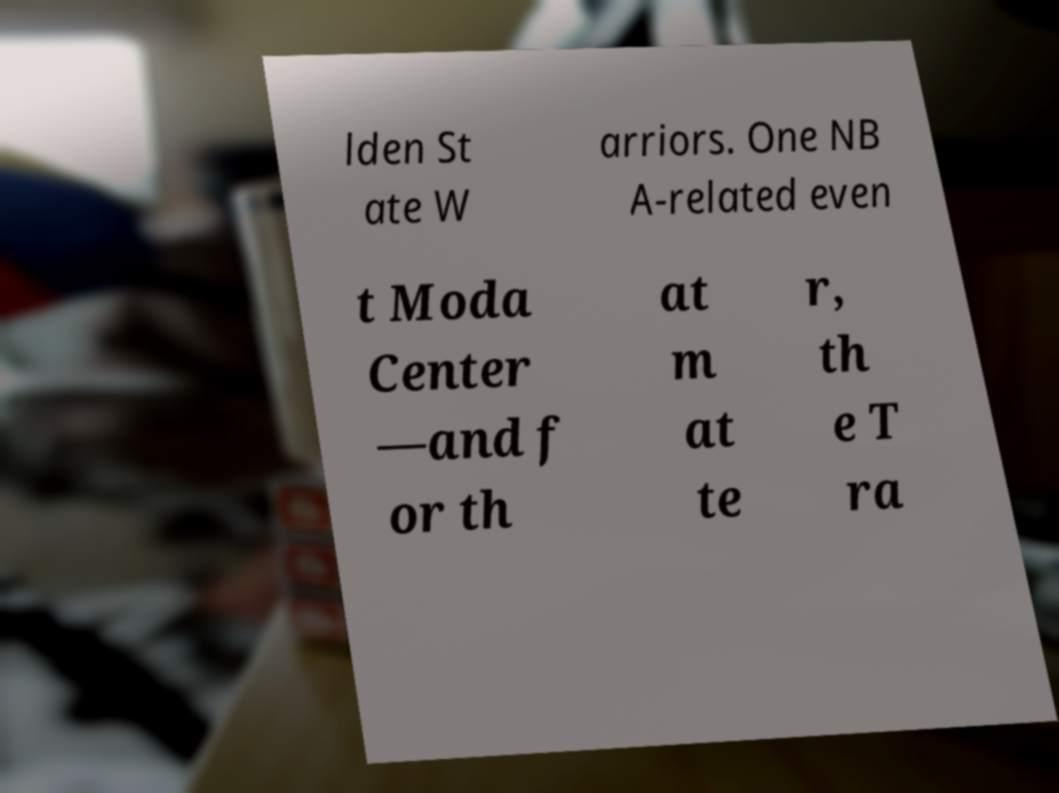Can you read and provide the text displayed in the image?This photo seems to have some interesting text. Can you extract and type it out for me? lden St ate W arriors. One NB A-related even t Moda Center —and f or th at m at te r, th e T ra 